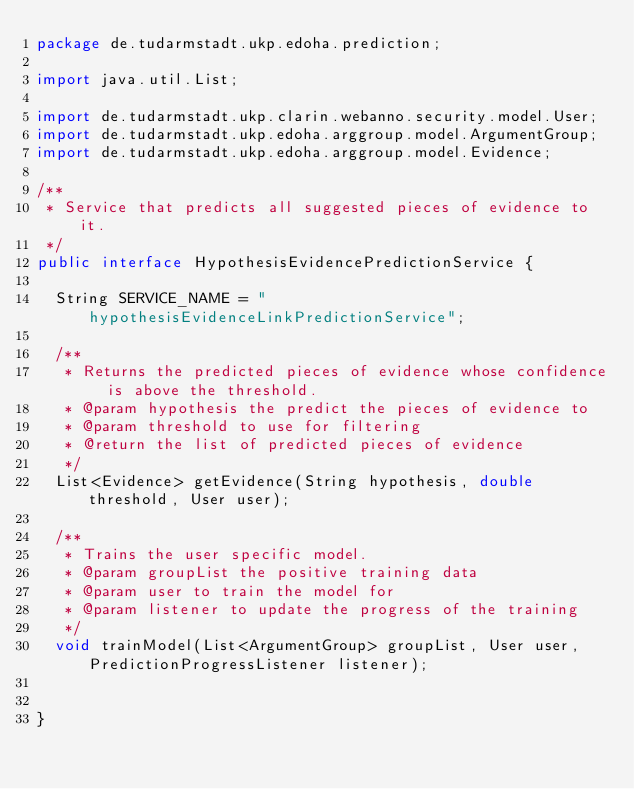<code> <loc_0><loc_0><loc_500><loc_500><_Java_>package de.tudarmstadt.ukp.edoha.prediction;

import java.util.List;

import de.tudarmstadt.ukp.clarin.webanno.security.model.User;
import de.tudarmstadt.ukp.edoha.arggroup.model.ArgumentGroup;
import de.tudarmstadt.ukp.edoha.arggroup.model.Evidence;

/**
 * Service that predicts all suggested pieces of evidence to it.
 */
public interface HypothesisEvidencePredictionService {
	
	String SERVICE_NAME = "hypothesisEvidenceLinkPredictionService";

	/**
	 * Returns the predicted pieces of evidence whose confidence is above the threshold.
	 * @param hypothesis the predict the pieces of evidence to 
	 * @param threshold to use for filtering
	 * @return the list of predicted pieces of evidence
	 */
	List<Evidence> getEvidence(String hypothesis, double threshold, User user);
	
	/**
	 * Trains the user specific model.
	 * @param groupList the positive training data
	 * @param user to train the model for
	 * @param listener to update the progress of the training
	 */
	void trainModel(List<ArgumentGroup> groupList, User user, PredictionProgressListener listener);


}
</code> 